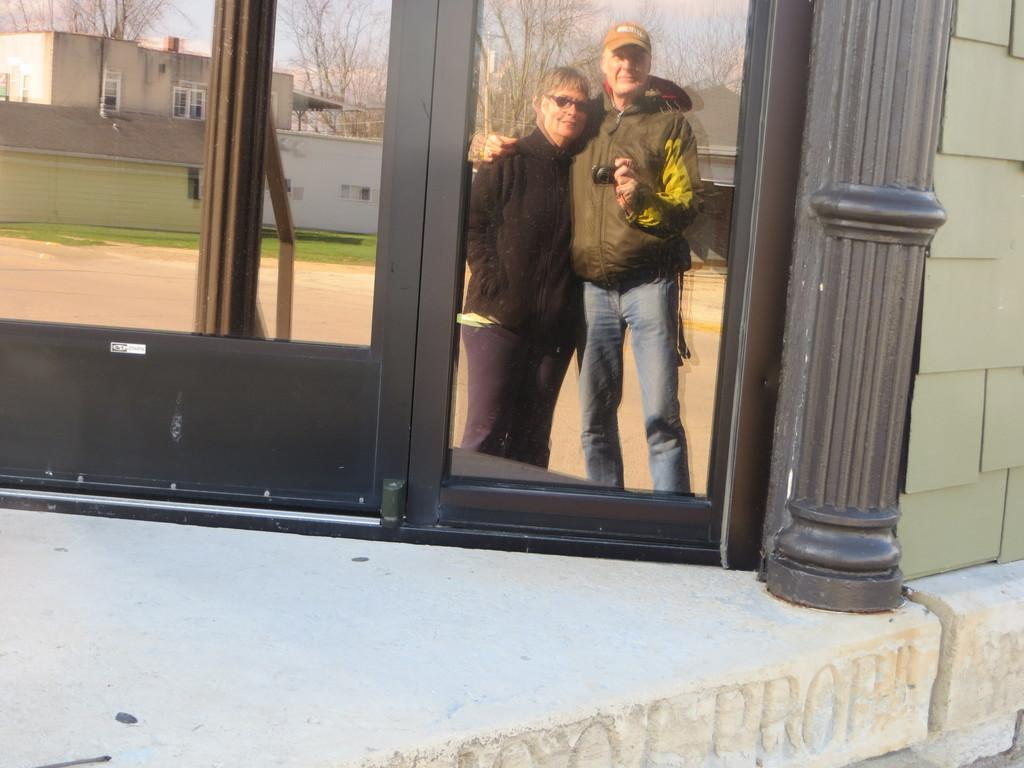What type of structure is visible in the image? There is a house in the image. What is the material of the window in the image? The window in the image is made of glass. What type of vegetation can be seen in the image? There are trees and grass in the image. How many people are present in the image? There are two persons standing in the image. Can you see a nest in the throat of one of the persons in the image? There is no nest visible in the image, nor is there any indication of a nest in someone's throat. 